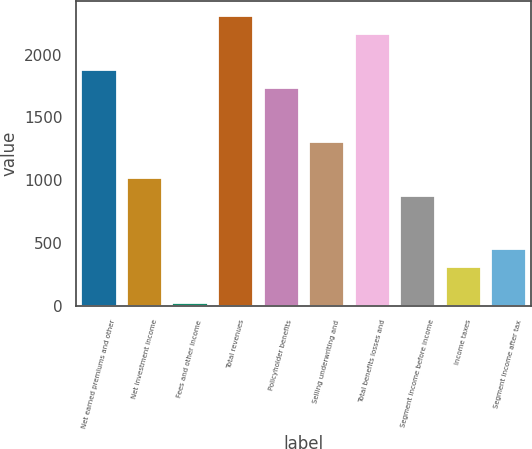Convert chart. <chart><loc_0><loc_0><loc_500><loc_500><bar_chart><fcel>Net earned premiums and other<fcel>Net investment income<fcel>Fees and other income<fcel>Total revenues<fcel>Policyholder benefits<fcel>Selling underwriting and<fcel>Total benefits losses and<fcel>Segment income before income<fcel>Income taxes<fcel>Segment income after tax<nl><fcel>1884.1<fcel>1027.9<fcel>29<fcel>2312.2<fcel>1741.4<fcel>1313.3<fcel>2169.5<fcel>885.2<fcel>314.4<fcel>457.1<nl></chart> 